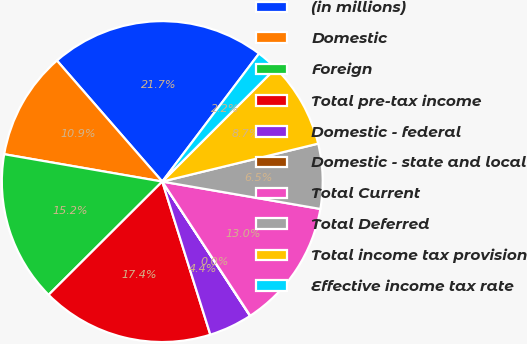<chart> <loc_0><loc_0><loc_500><loc_500><pie_chart><fcel>(in millions)<fcel>Domestic<fcel>Foreign<fcel>Total pre-tax income<fcel>Domestic - federal<fcel>Domestic - state and local<fcel>Total Current<fcel>Total Deferred<fcel>Total income tax provision<fcel>Effective income tax rate<nl><fcel>21.7%<fcel>10.87%<fcel>15.2%<fcel>17.37%<fcel>4.37%<fcel>0.03%<fcel>13.03%<fcel>6.53%<fcel>8.7%<fcel>2.2%<nl></chart> 